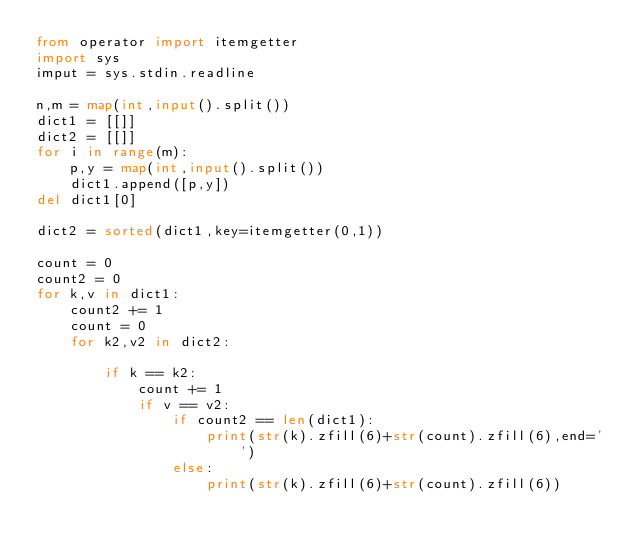Convert code to text. <code><loc_0><loc_0><loc_500><loc_500><_Python_>from operator import itemgetter
import sys
imput = sys.stdin.readline

n,m = map(int,input().split())
dict1 = [[]]
dict2 = [[]]
for i in range(m):
    p,y = map(int,input().split())
    dict1.append([p,y])
del dict1[0]

dict2 = sorted(dict1,key=itemgetter(0,1))

count = 0
count2 = 0
for k,v in dict1:
    count2 += 1
    count = 0
    for k2,v2 in dict2:
    
        if k == k2:
            count += 1
            if v == v2:
                if count2 == len(dict1):
                    print(str(k).zfill(6)+str(count).zfill(6),end='')
                else:
                    print(str(k).zfill(6)+str(count).zfill(6))</code> 